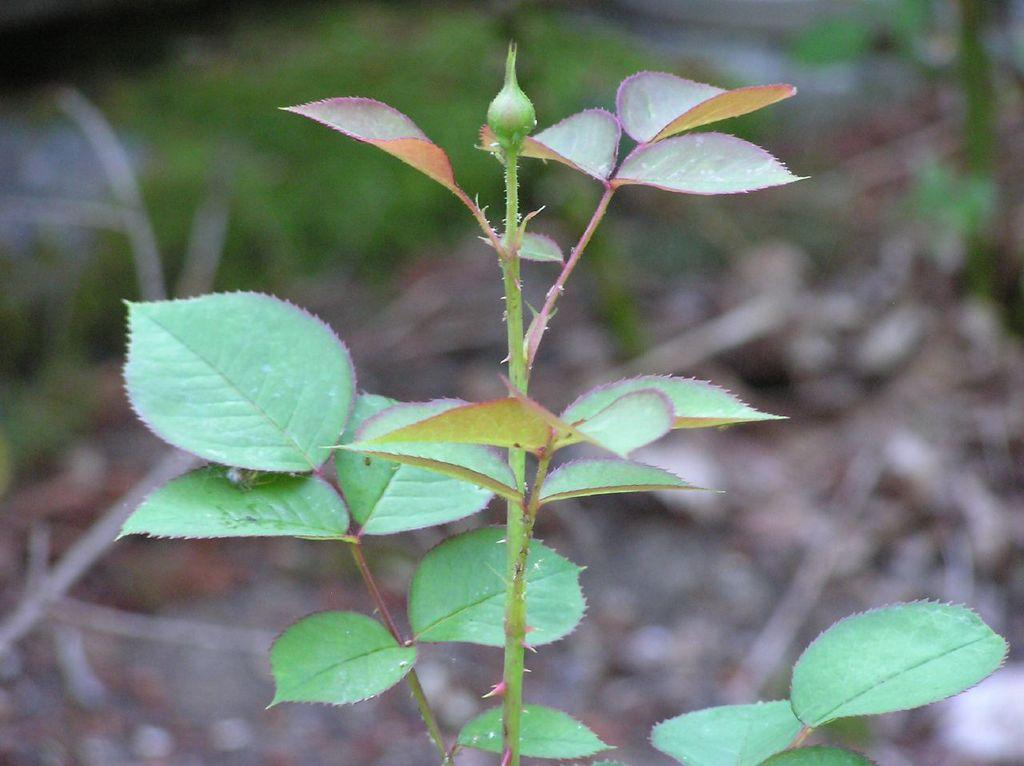What is the main subject of the image? The main subject of the image is a bud of a plant. Can you describe the background of the image? The background of the image is blurred. What type of quill can be seen in the image? There is no quill present in the image. How many houses are visible in the image? There are no houses visible in the image. Can you tell me where the kitty is hiding in the image? There is no kitty present in the image. 